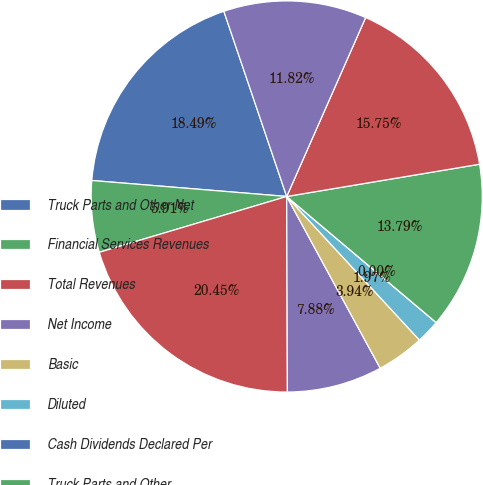Convert chart. <chart><loc_0><loc_0><loc_500><loc_500><pie_chart><fcel>Truck Parts and Other Net<fcel>Financial Services Revenues<fcel>Total Revenues<fcel>Net Income<fcel>Basic<fcel>Diluted<fcel>Cash Dividends Declared Per<fcel>Truck Parts and Other<fcel>Financial Services<fcel>Financial Services Debt<nl><fcel>18.49%<fcel>5.91%<fcel>20.45%<fcel>7.88%<fcel>3.94%<fcel>1.97%<fcel>0.0%<fcel>13.79%<fcel>15.75%<fcel>11.82%<nl></chart> 